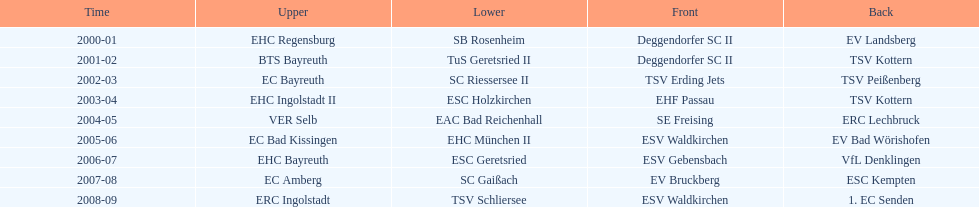Parse the full table. {'header': ['Time', 'Upper', 'Lower', 'Front', 'Back'], 'rows': [['2000-01', 'EHC Regensburg', 'SB Rosenheim', 'Deggendorfer SC II', 'EV Landsberg'], ['2001-02', 'BTS Bayreuth', 'TuS Geretsried II', 'Deggendorfer SC II', 'TSV Kottern'], ['2002-03', 'EC Bayreuth', 'SC Riessersee II', 'TSV Erding Jets', 'TSV Peißenberg'], ['2003-04', 'EHC Ingolstadt II', 'ESC Holzkirchen', 'EHF Passau', 'TSV Kottern'], ['2004-05', 'VER Selb', 'EAC Bad Reichenhall', 'SE Freising', 'ERC Lechbruck'], ['2005-06', 'EC Bad Kissingen', 'EHC München II', 'ESV Waldkirchen', 'EV Bad Wörishofen'], ['2006-07', 'EHC Bayreuth', 'ESC Geretsried', 'ESV Gebensbach', 'VfL Denklingen'], ['2007-08', 'EC Amberg', 'SC Gaißach', 'EV Bruckberg', 'ESC Kempten'], ['2008-09', 'ERC Ingolstadt', 'TSV Schliersee', 'ESV Waldkirchen', '1. EC Senden']]} Starting with the 2007 - 08 season, does ecs kempten appear in any of the previous years? No. 